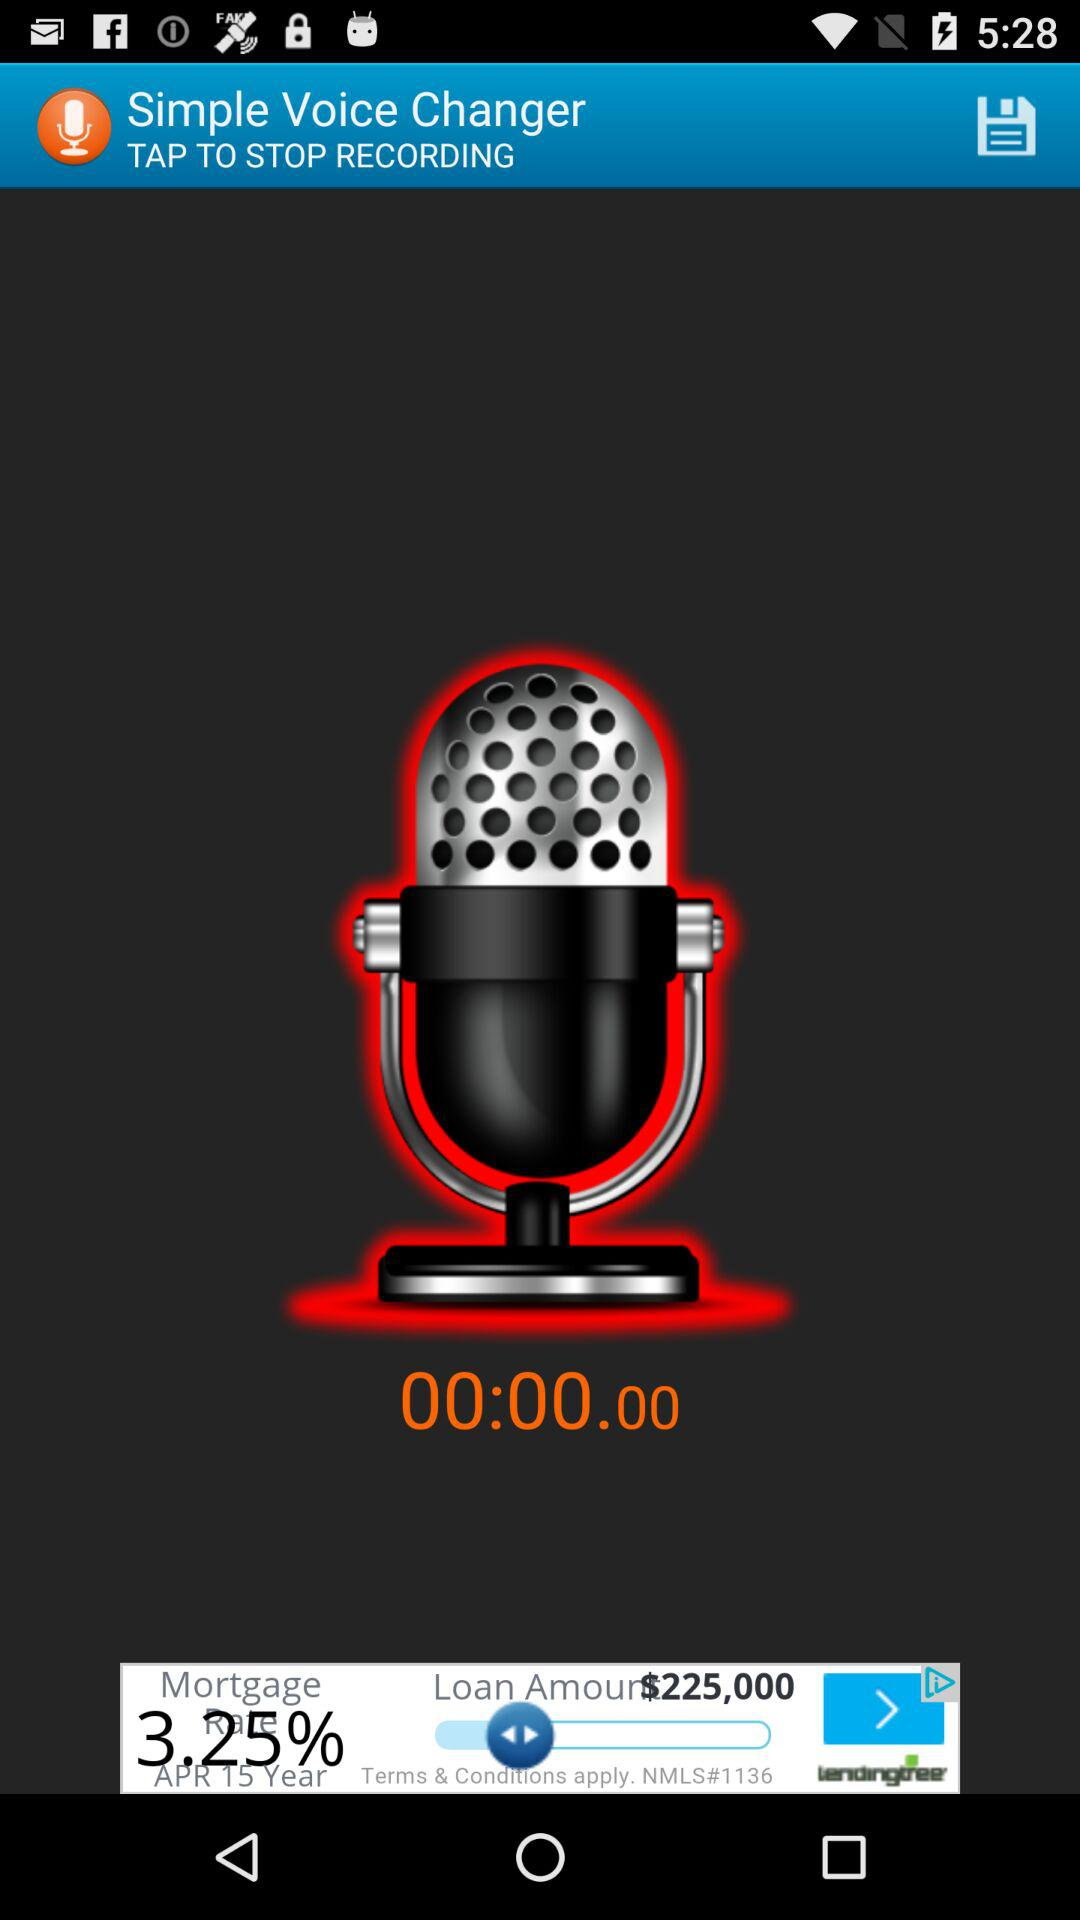What is the length of the time elapsed?
Answer the question using a single word or phrase. 00:00:00 